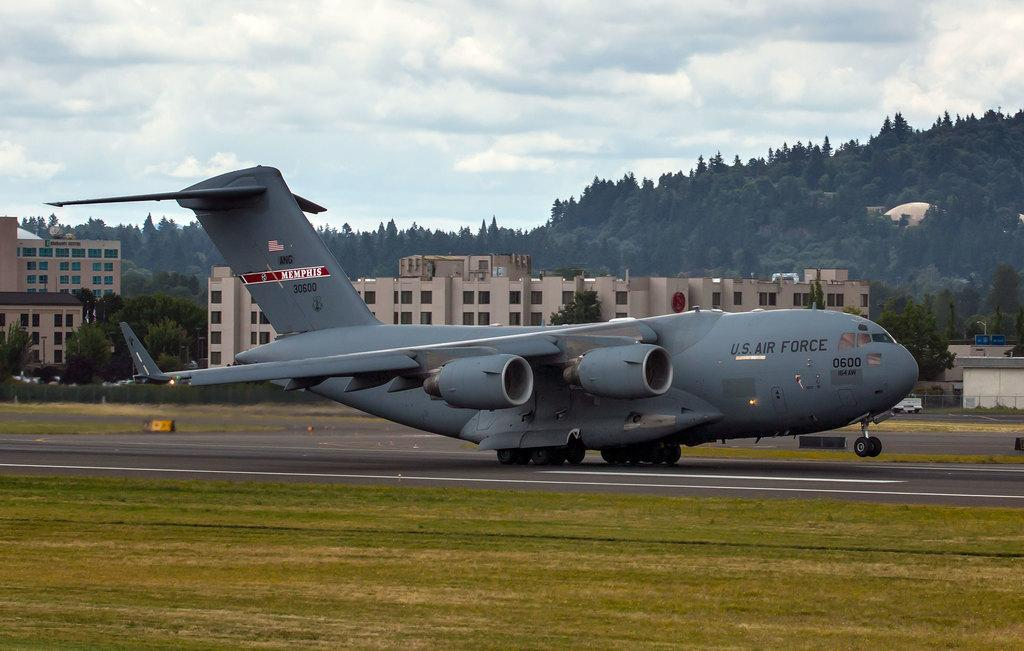<image>
Create a compact narrative representing the image presented. a US Air Force plane is about to take off from a runway 